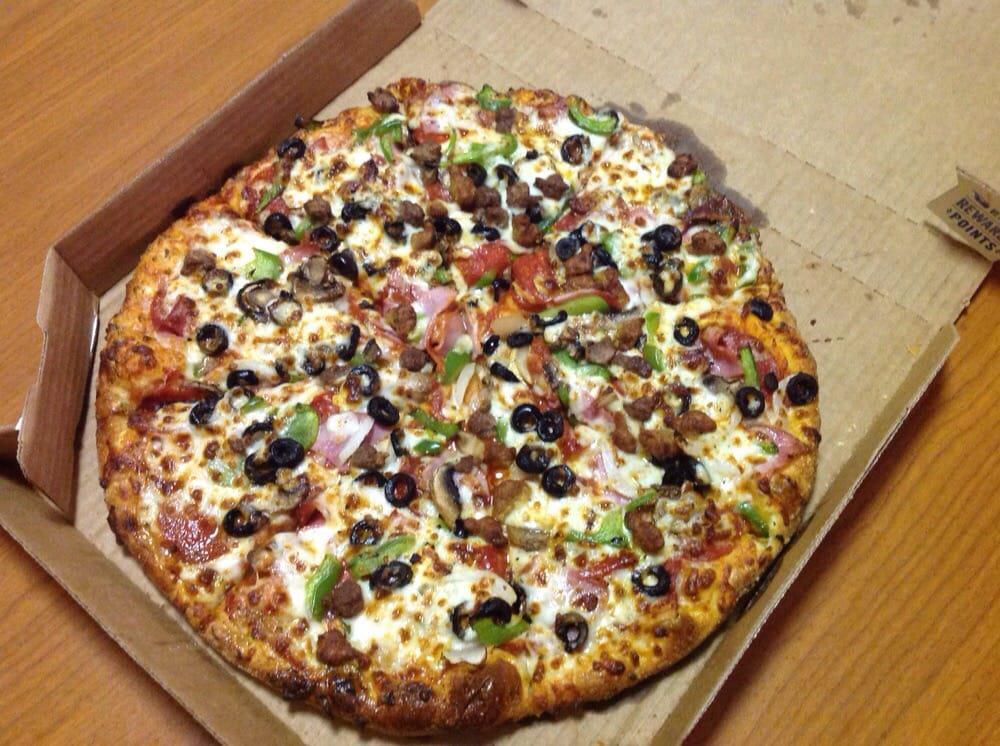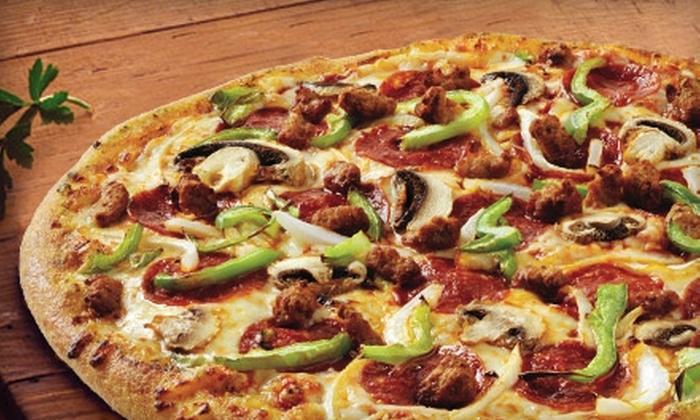The first image is the image on the left, the second image is the image on the right. For the images shown, is this caption "The left image features an uncut square pizza, and the right image contains at least part of a sliced round pizza." true? Answer yes or no. No. The first image is the image on the left, the second image is the image on the right. Given the left and right images, does the statement "There is one round pizza in each image." hold true? Answer yes or no. Yes. 